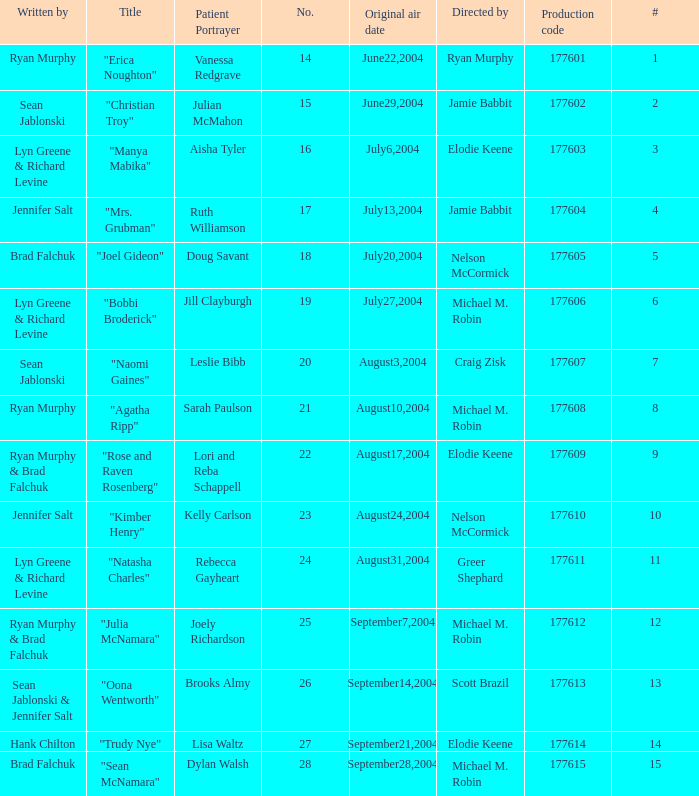How many episodes are numbered 4 in the season? 1.0. 